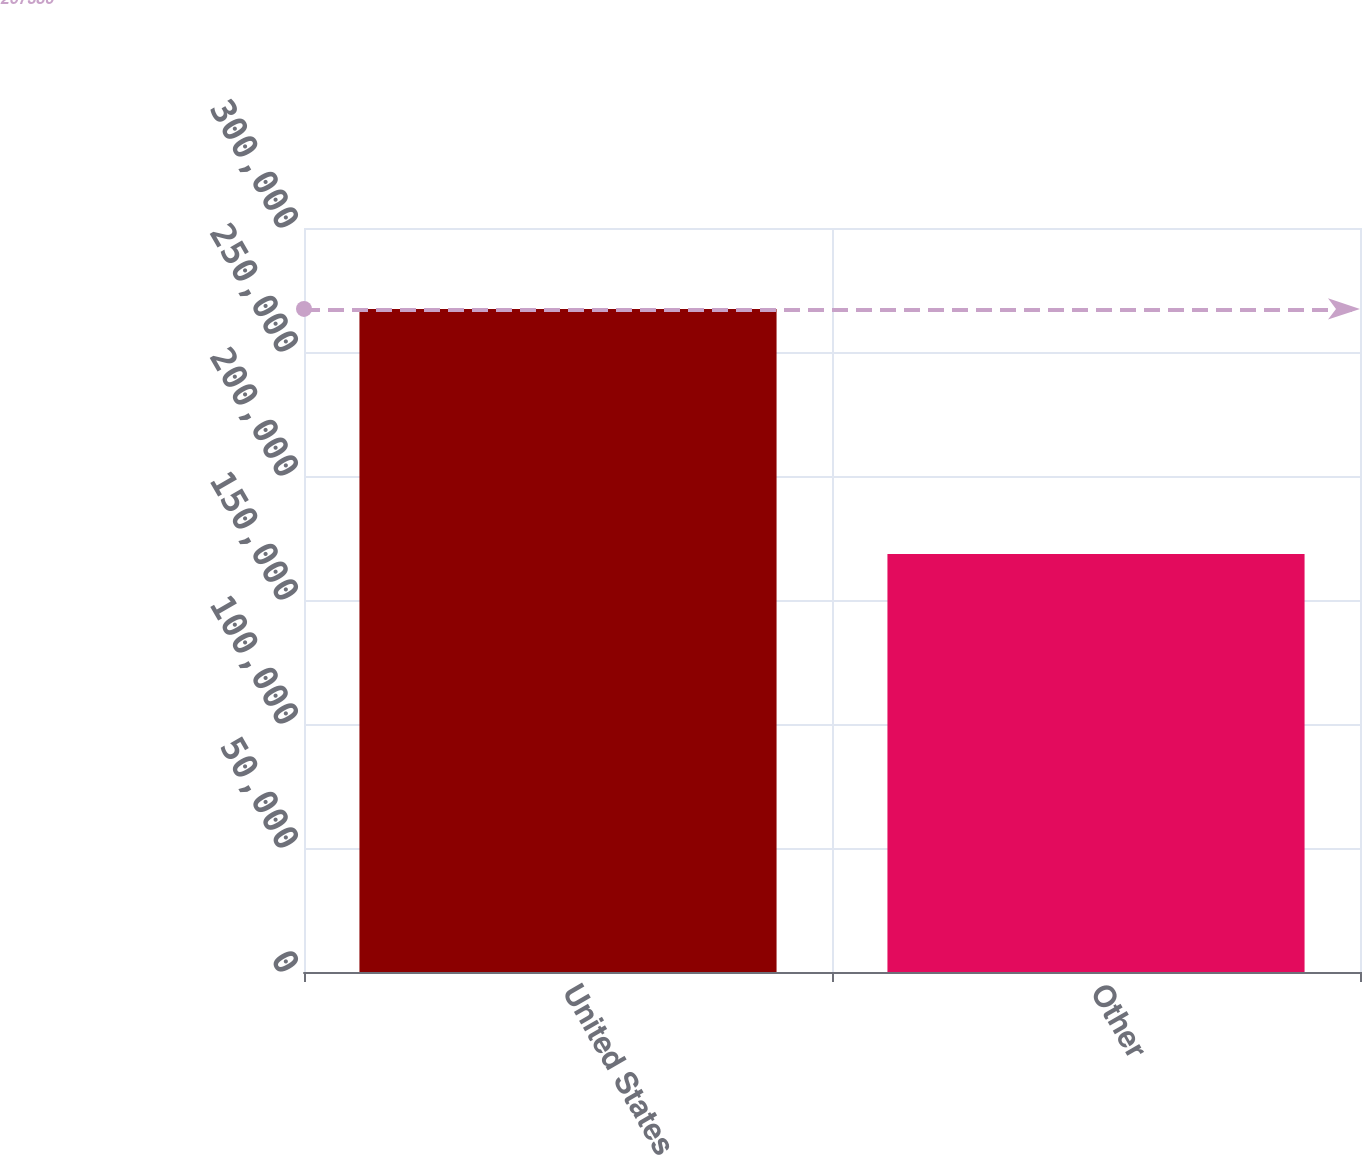Convert chart to OTSL. <chart><loc_0><loc_0><loc_500><loc_500><bar_chart><fcel>United States<fcel>Other<nl><fcel>267386<fcel>168569<nl></chart> 